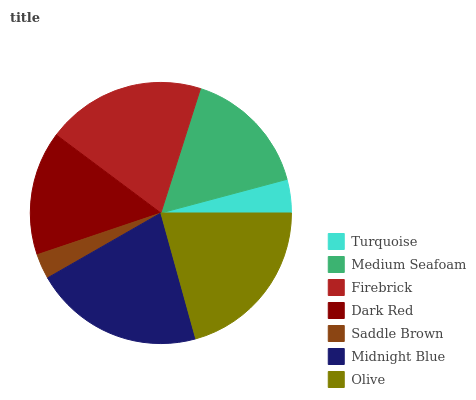Is Saddle Brown the minimum?
Answer yes or no. Yes. Is Midnight Blue the maximum?
Answer yes or no. Yes. Is Medium Seafoam the minimum?
Answer yes or no. No. Is Medium Seafoam the maximum?
Answer yes or no. No. Is Medium Seafoam greater than Turquoise?
Answer yes or no. Yes. Is Turquoise less than Medium Seafoam?
Answer yes or no. Yes. Is Turquoise greater than Medium Seafoam?
Answer yes or no. No. Is Medium Seafoam less than Turquoise?
Answer yes or no. No. Is Medium Seafoam the high median?
Answer yes or no. Yes. Is Medium Seafoam the low median?
Answer yes or no. Yes. Is Turquoise the high median?
Answer yes or no. No. Is Firebrick the low median?
Answer yes or no. No. 